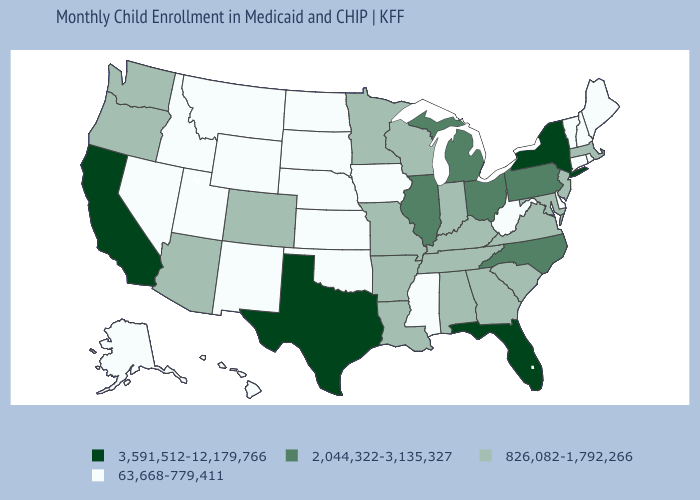Does the map have missing data?
Keep it brief. No. Among the states that border Wyoming , does Colorado have the lowest value?
Answer briefly. No. Does the map have missing data?
Be succinct. No. What is the value of Virginia?
Write a very short answer. 826,082-1,792,266. Among the states that border Rhode Island , which have the highest value?
Concise answer only. Massachusetts. Name the states that have a value in the range 3,591,512-12,179,766?
Answer briefly. California, Florida, New York, Texas. What is the lowest value in the USA?
Short answer required. 63,668-779,411. Does the map have missing data?
Be succinct. No. What is the lowest value in the USA?
Write a very short answer. 63,668-779,411. Does Texas have the highest value in the USA?
Answer briefly. Yes. What is the value of Alaska?
Give a very brief answer. 63,668-779,411. Which states have the lowest value in the South?
Short answer required. Delaware, Mississippi, Oklahoma, West Virginia. Name the states that have a value in the range 3,591,512-12,179,766?
Concise answer only. California, Florida, New York, Texas. What is the value of South Dakota?
Quick response, please. 63,668-779,411. What is the highest value in states that border Arkansas?
Be succinct. 3,591,512-12,179,766. 